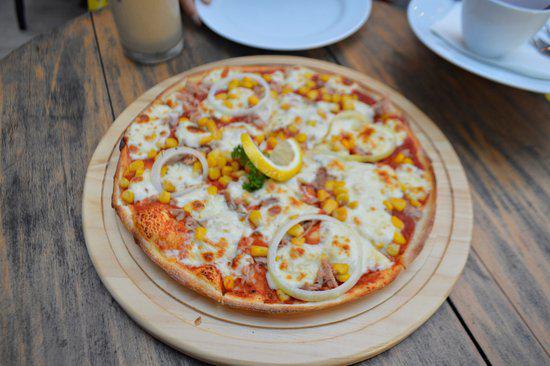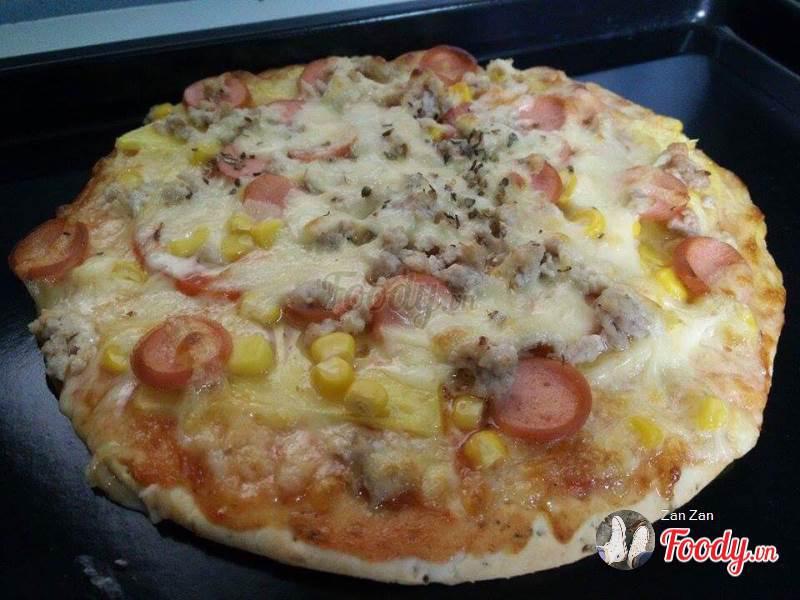The first image is the image on the left, the second image is the image on the right. Considering the images on both sides, is "The pizza on the left has citrus on top." valid? Answer yes or no. Yes. The first image is the image on the left, the second image is the image on the right. Analyze the images presented: Is the assertion "There is at least one lemon on top of the pizza." valid? Answer yes or no. Yes. 